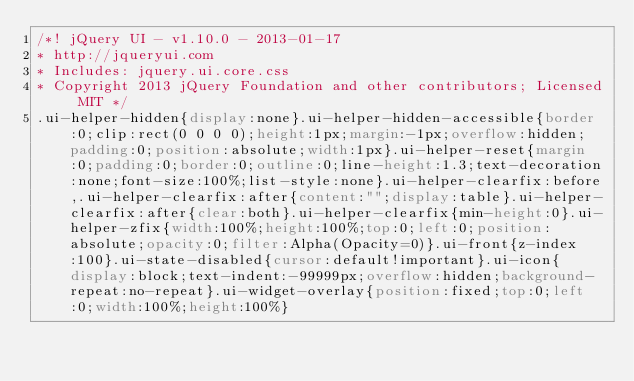<code> <loc_0><loc_0><loc_500><loc_500><_CSS_>/*! jQuery UI - v1.10.0 - 2013-01-17
* http://jqueryui.com
* Includes: jquery.ui.core.css
* Copyright 2013 jQuery Foundation and other contributors; Licensed MIT */
.ui-helper-hidden{display:none}.ui-helper-hidden-accessible{border:0;clip:rect(0 0 0 0);height:1px;margin:-1px;overflow:hidden;padding:0;position:absolute;width:1px}.ui-helper-reset{margin:0;padding:0;border:0;outline:0;line-height:1.3;text-decoration:none;font-size:100%;list-style:none}.ui-helper-clearfix:before,.ui-helper-clearfix:after{content:"";display:table}.ui-helper-clearfix:after{clear:both}.ui-helper-clearfix{min-height:0}.ui-helper-zfix{width:100%;height:100%;top:0;left:0;position:absolute;opacity:0;filter:Alpha(Opacity=0)}.ui-front{z-index:100}.ui-state-disabled{cursor:default!important}.ui-icon{display:block;text-indent:-99999px;overflow:hidden;background-repeat:no-repeat}.ui-widget-overlay{position:fixed;top:0;left:0;width:100%;height:100%}</code> 